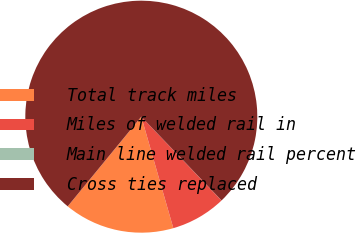<chart> <loc_0><loc_0><loc_500><loc_500><pie_chart><fcel>Total track miles<fcel>Miles of welded rail in<fcel>Main line welded rail percent<fcel>Cross ties replaced<nl><fcel>15.39%<fcel>7.7%<fcel>0.01%<fcel>76.91%<nl></chart> 